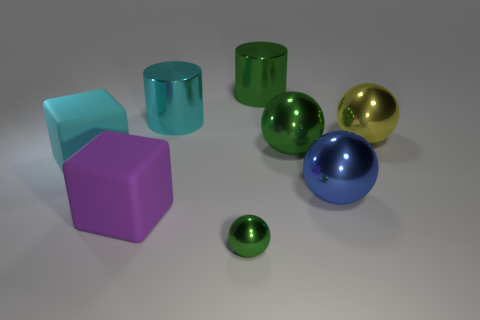What number of purple objects are small blocks or spheres?
Your answer should be compact. 0. There is another big cylinder that is made of the same material as the green cylinder; what color is it?
Keep it short and to the point. Cyan. Is the material of the cylinder that is on the right side of the small green sphere the same as the big green object in front of the big yellow metallic thing?
Offer a very short reply. Yes. There is a metallic cylinder that is the same color as the tiny shiny ball; what is its size?
Keep it short and to the point. Large. There is a big cyan object in front of the yellow metal thing; what is it made of?
Provide a short and direct response. Rubber. There is a cyan object that is on the left side of the purple cube; is its shape the same as the large metallic object to the left of the tiny green sphere?
Make the answer very short. No. Is there a big yellow cylinder?
Your answer should be very brief. No. There is a large green thing that is the same shape as the cyan metal thing; what is its material?
Keep it short and to the point. Metal. There is a big blue metallic sphere; are there any big blue metallic things behind it?
Your answer should be very brief. No. Do the large green thing behind the yellow metallic object and the small ball have the same material?
Your answer should be compact. Yes. 